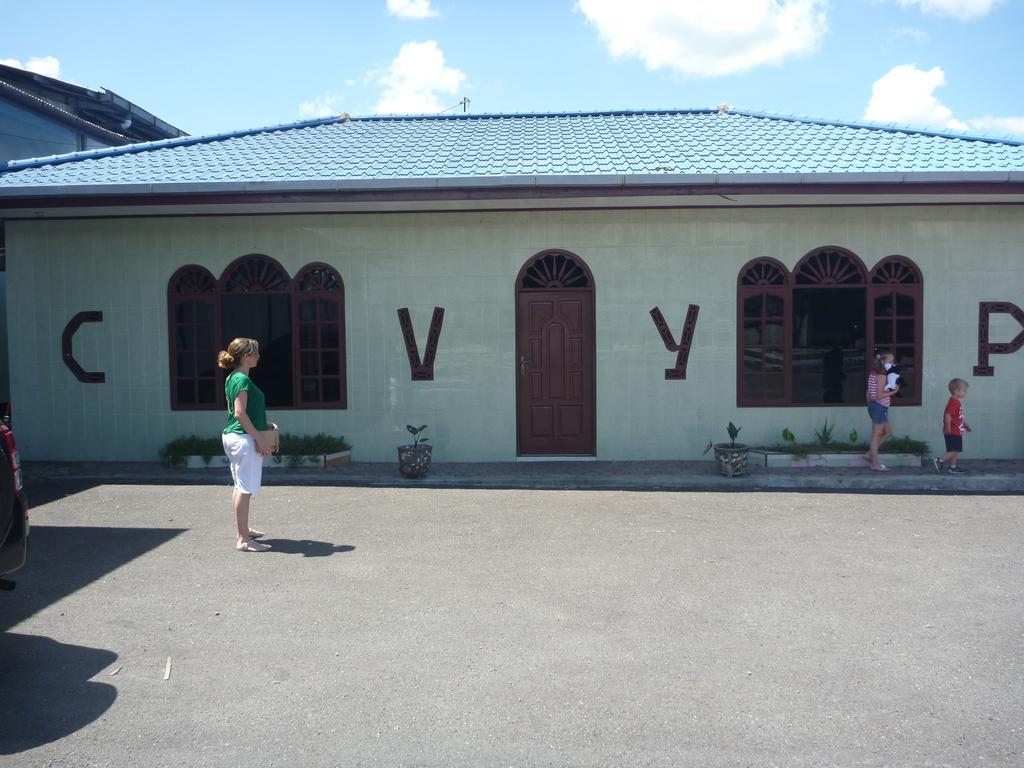Describe this image in one or two sentences. In this image on the left side we can see a woman is standing by holding an object in her hands on the road and there is a vehicle. On the right side there are two kids walking at the house and we can see windows, doors, house plants, roof and in the background there are buildings, pole and clouds in the sky. 